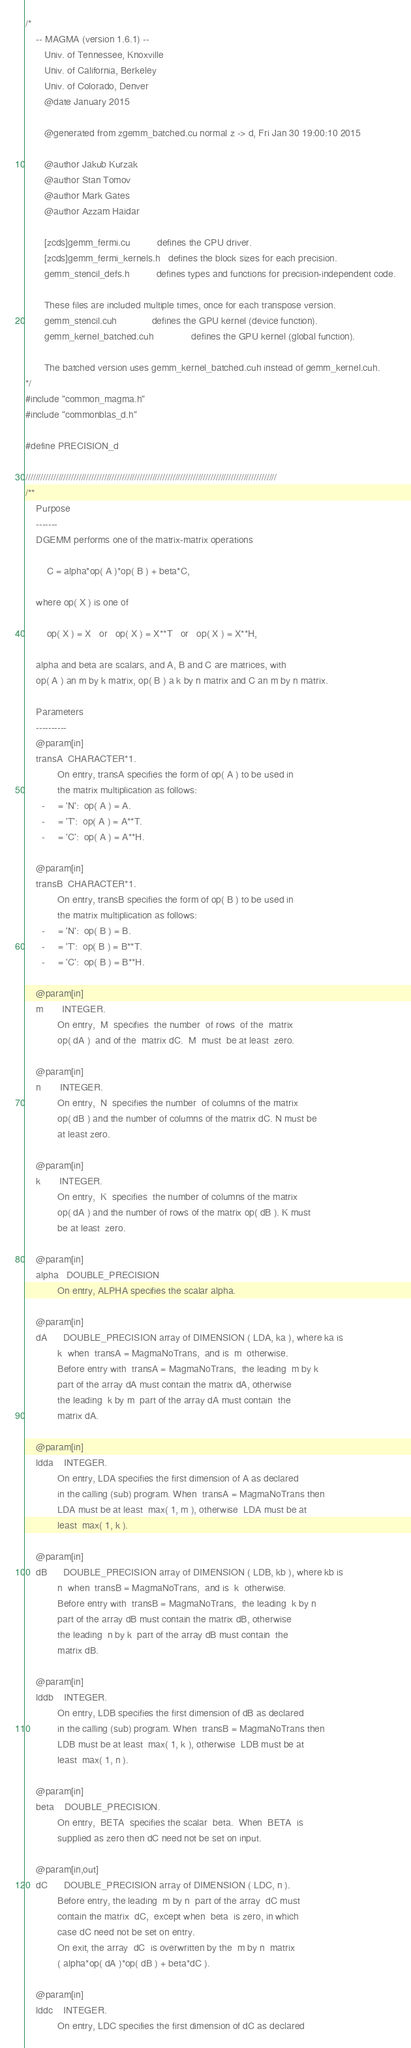Convert code to text. <code><loc_0><loc_0><loc_500><loc_500><_Cuda_>/*
    -- MAGMA (version 1.6.1) --
       Univ. of Tennessee, Knoxville
       Univ. of California, Berkeley
       Univ. of Colorado, Denver
       @date January 2015

       @generated from zgemm_batched.cu normal z -> d, Fri Jan 30 19:00:10 2015

       @author Jakub Kurzak
       @author Stan Tomov
       @author Mark Gates
       @author Azzam Haidar

       [zcds]gemm_fermi.cu          defines the CPU driver.
       [zcds]gemm_fermi_kernels.h   defines the block sizes for each precision.
       gemm_stencil_defs.h          defines types and functions for precision-independent code.
       
       These files are included multiple times, once for each transpose version.
       gemm_stencil.cuh             defines the GPU kernel (device function).
       gemm_kernel_batched.cuh              defines the GPU kernel (global function).
       
       The batched version uses gemm_kernel_batched.cuh instead of gemm_kernel.cuh.
*/
#include "common_magma.h"
#include "commonblas_d.h"

#define PRECISION_d

///////////////////////////////////////////////////////////////////////////////////////////////////
/**
    Purpose
    -------
    DGEMM performs one of the matrix-matrix operations
    
        C = alpha*op( A )*op( B ) + beta*C,
    
    where op( X ) is one of
    
        op( X ) = X   or   op( X ) = X**T   or   op( X ) = X**H,
    
    alpha and beta are scalars, and A, B and C are matrices, with
    op( A ) an m by k matrix, op( B ) a k by n matrix and C an m by n matrix.
    
    Parameters
    ----------
    @param[in]
    transA  CHARACTER*1.
            On entry, transA specifies the form of op( A ) to be used in
            the matrix multiplication as follows:
      -     = 'N':  op( A ) = A.
      -     = 'T':  op( A ) = A**T.
      -     = 'C':  op( A ) = A**H.
    
    @param[in]
    transB  CHARACTER*1.
            On entry, transB specifies the form of op( B ) to be used in
            the matrix multiplication as follows:
      -     = 'N':  op( B ) = B.
      -     = 'T':  op( B ) = B**T.
      -     = 'C':  op( B ) = B**H.
    
    @param[in]
    m       INTEGER.
            On entry,  M  specifies  the number  of rows  of the  matrix
            op( dA )  and of the  matrix dC.  M  must  be at least  zero.
    
    @param[in]
    n       INTEGER.
            On entry,  N  specifies the number  of columns of the matrix
            op( dB ) and the number of columns of the matrix dC. N must be
            at least zero.
    
    @param[in]
    k       INTEGER.
            On entry,  K  specifies  the number of columns of the matrix
            op( dA ) and the number of rows of the matrix op( dB ). K must
            be at least  zero.
    
    @param[in]
    alpha   DOUBLE_PRECISION
            On entry, ALPHA specifies the scalar alpha.
    
    @param[in]
    dA      DOUBLE_PRECISION array of DIMENSION ( LDA, ka ), where ka is
            k  when  transA = MagmaNoTrans,  and is  m  otherwise.
            Before entry with  transA = MagmaNoTrans,  the leading  m by k
            part of the array dA must contain the matrix dA, otherwise
            the leading  k by m  part of the array dA must contain  the
            matrix dA.
    
    @param[in]
    ldda    INTEGER.
            On entry, LDA specifies the first dimension of A as declared
            in the calling (sub) program. When  transA = MagmaNoTrans then
            LDA must be at least  max( 1, m ), otherwise  LDA must be at
            least  max( 1, k ).
    
    @param[in]
    dB      DOUBLE_PRECISION array of DIMENSION ( LDB, kb ), where kb is
            n  when  transB = MagmaNoTrans,  and is  k  otherwise.
            Before entry with  transB = MagmaNoTrans,  the leading  k by n
            part of the array dB must contain the matrix dB, otherwise
            the leading  n by k  part of the array dB must contain  the
            matrix dB.
    
    @param[in]
    lddb    INTEGER.
            On entry, LDB specifies the first dimension of dB as declared
            in the calling (sub) program. When  transB = MagmaNoTrans then
            LDB must be at least  max( 1, k ), otherwise  LDB must be at
            least  max( 1, n ).
    
    @param[in]
    beta    DOUBLE_PRECISION.
            On entry,  BETA  specifies the scalar  beta.  When  BETA  is
            supplied as zero then dC need not be set on input.
    
    @param[in,out]
    dC      DOUBLE_PRECISION array of DIMENSION ( LDC, n ).
            Before entry, the leading  m by n  part of the array  dC must
            contain the matrix  dC,  except when  beta  is zero, in which
            case dC need not be set on entry.
            On exit, the array  dC  is overwritten by the  m by n  matrix
            ( alpha*op( dA )*op( dB ) + beta*dC ).
    
    @param[in]
    lddc    INTEGER.
            On entry, LDC specifies the first dimension of dC as declared</code> 